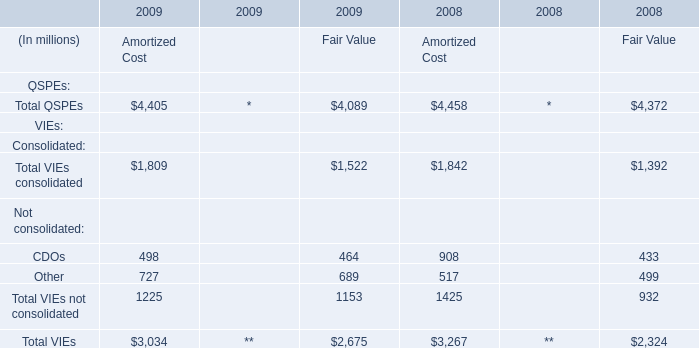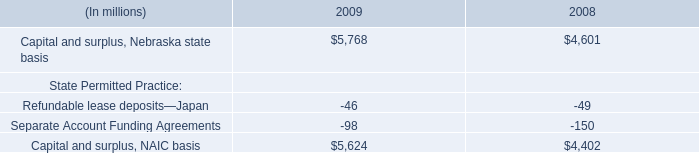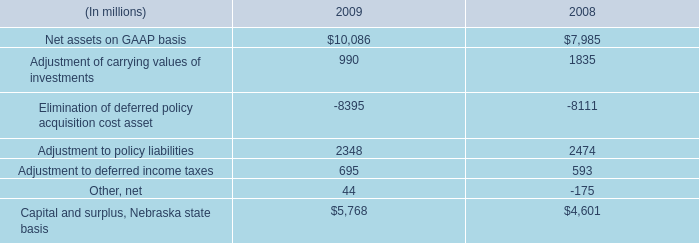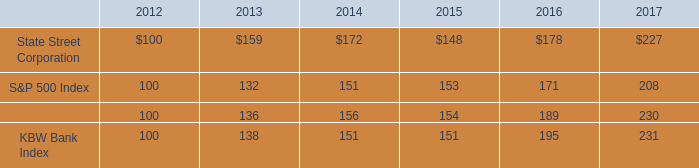what percent returns did shareholders of state street corporation 
Computations: ((227 - 100) / 100)
Answer: 1.27. 